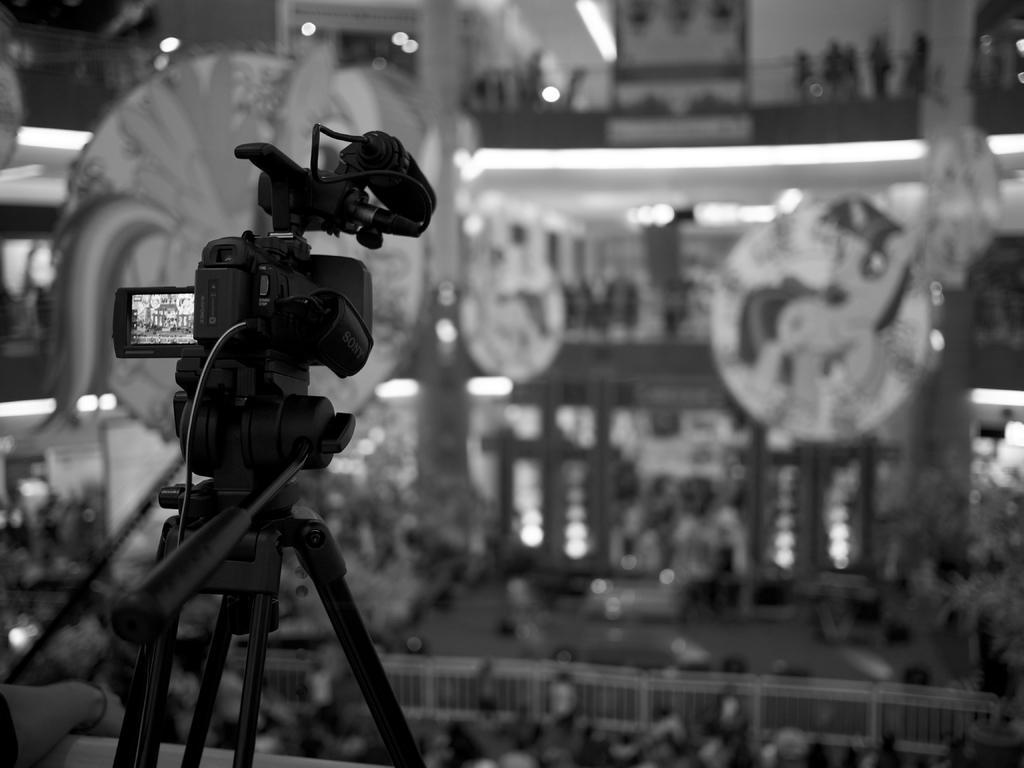How would you summarize this image in a sentence or two? This is a black and white image. In this image there is a video camera on a stand. In the background it is blurred. We can see railings and lights. 